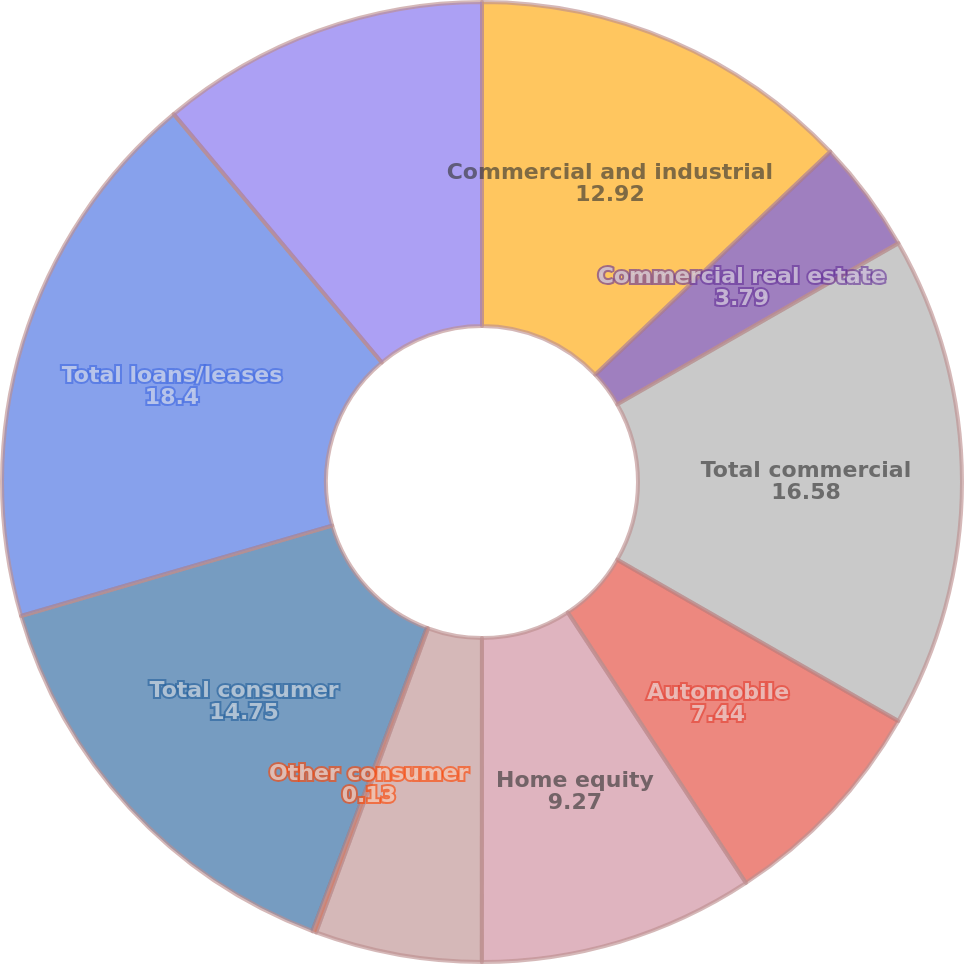Convert chart to OTSL. <chart><loc_0><loc_0><loc_500><loc_500><pie_chart><fcel>Commercial and industrial<fcel>Commercial real estate<fcel>Total commercial<fcel>Automobile<fcel>Home equity<fcel>Residential mortgage<fcel>Other consumer<fcel>Total consumer<fcel>Total loans/leases<fcel>Total securities<nl><fcel>12.92%<fcel>3.79%<fcel>16.58%<fcel>7.44%<fcel>9.27%<fcel>5.61%<fcel>0.13%<fcel>14.75%<fcel>18.4%<fcel>11.1%<nl></chart> 